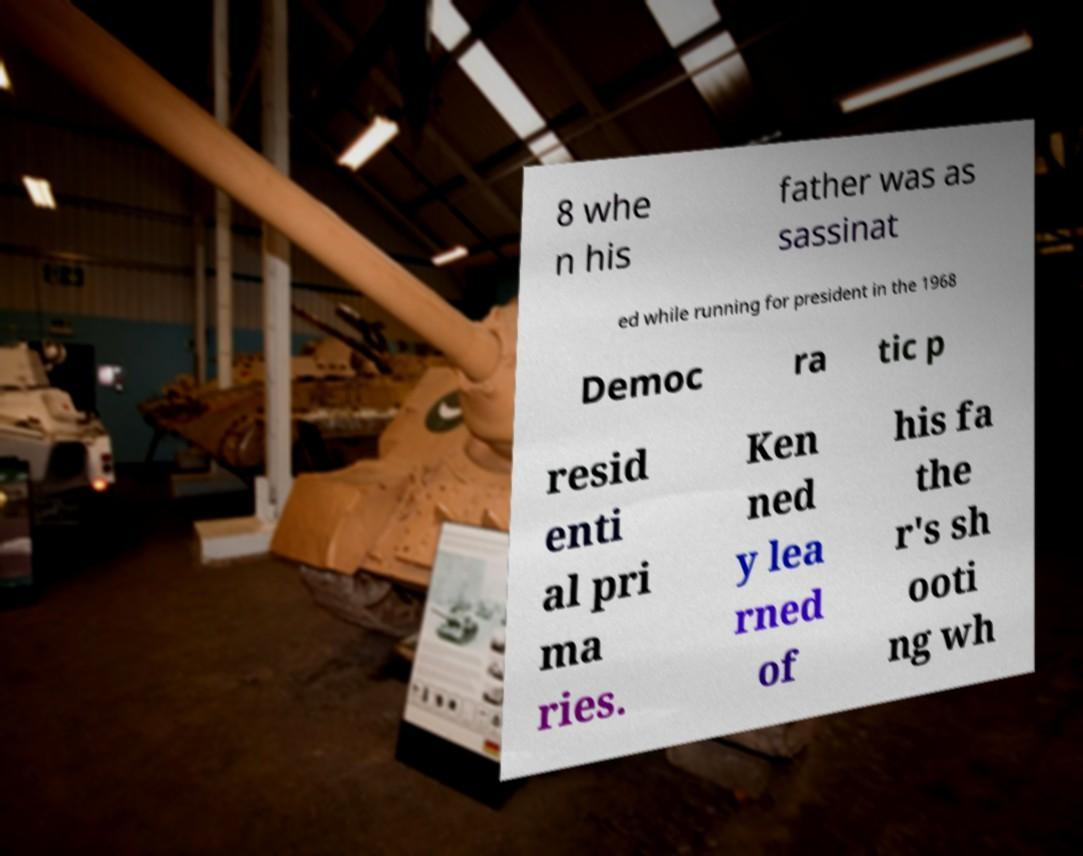Please identify and transcribe the text found in this image. 8 whe n his father was as sassinat ed while running for president in the 1968 Democ ra tic p resid enti al pri ma ries. Ken ned y lea rned of his fa the r's sh ooti ng wh 